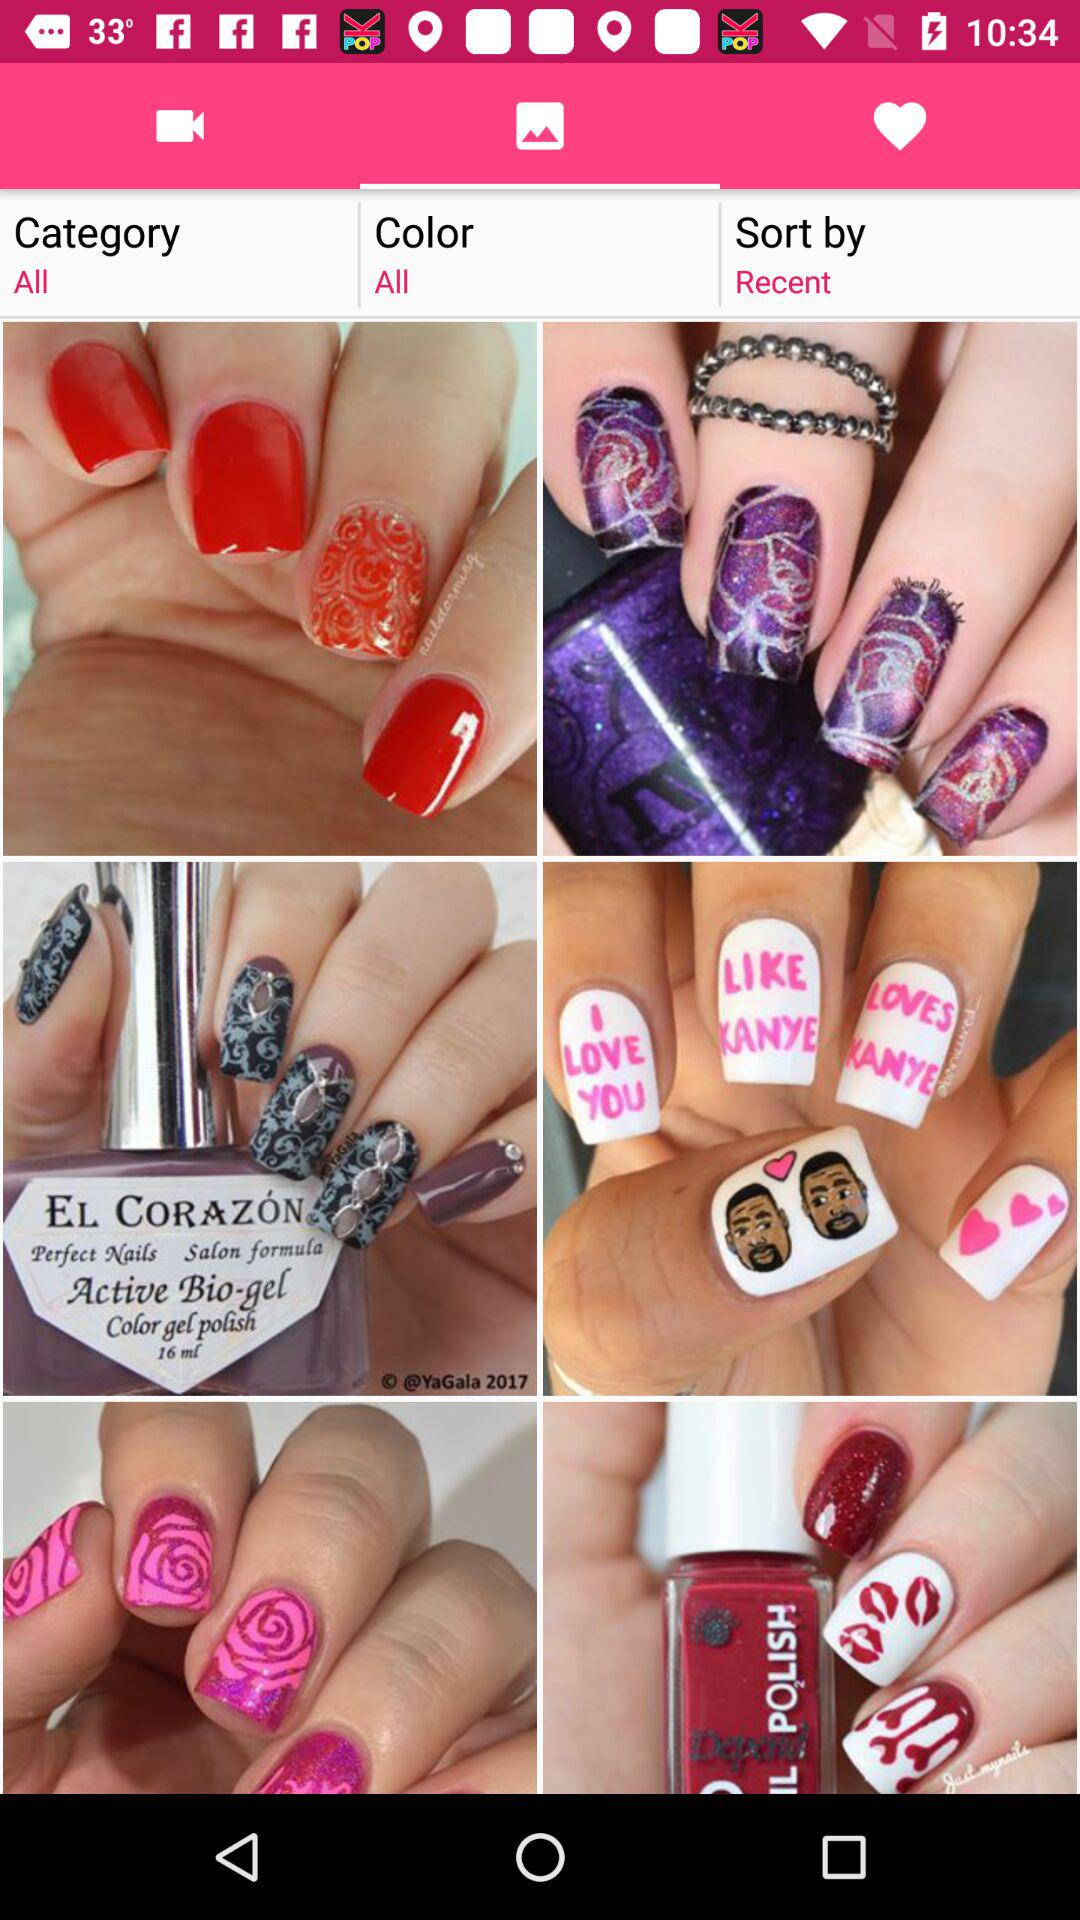Which tab am I on? You are on "Photos" tab. 